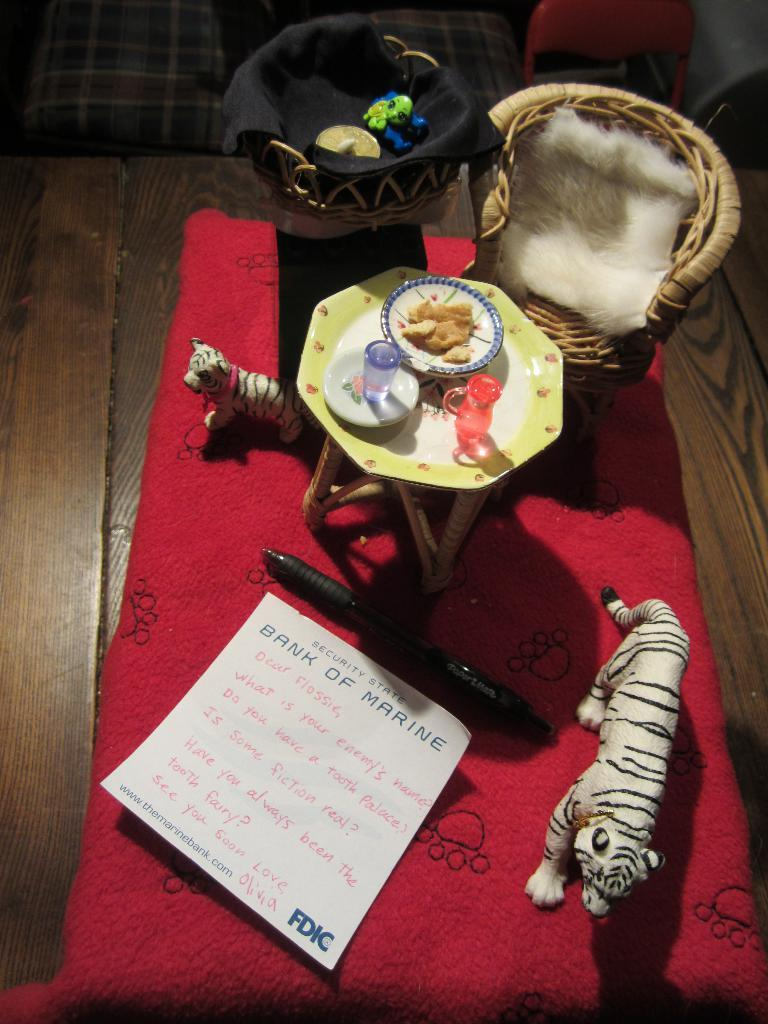What object is the main focus of the image? There is a greeting card in the image. What can be seen besides the greeting card? There is a pen and a toy of tigers in the image. What type of furniture is present in the image? There is a table in the image. What is unusual about the chairs in the image? Chairs are placed on the table in the image. What type of noise can be heard coming from the stove in the image? There is no stove present in the image, so it is not possible to determine what noise might be heard. 